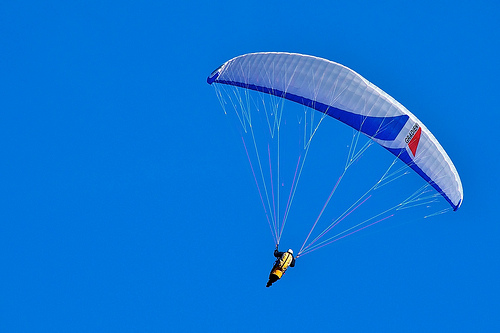Does the sky look cloudy? No, the sky appears to be clear and blue without any clouds. 